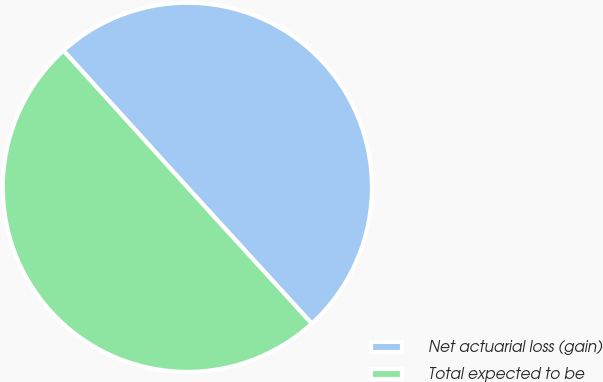Convert chart to OTSL. <chart><loc_0><loc_0><loc_500><loc_500><pie_chart><fcel>Net actuarial loss (gain)<fcel>Total expected to be<nl><fcel>49.95%<fcel>50.05%<nl></chart> 